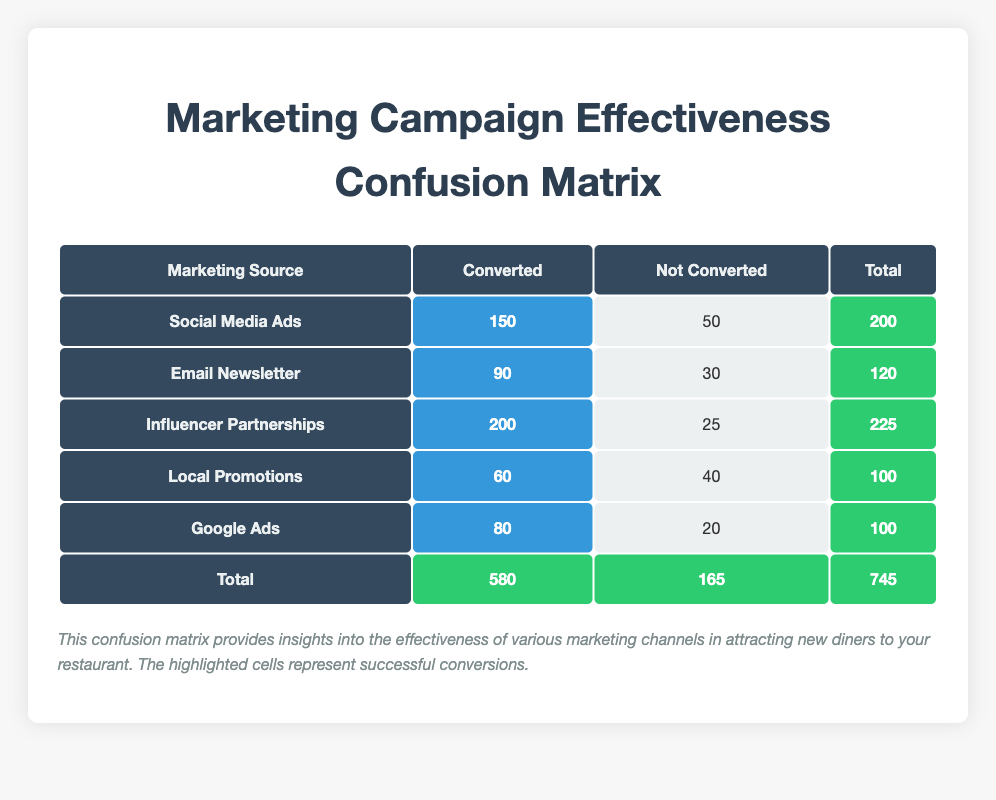What's the total number of conversions from Google Ads? In the table, the row corresponding to Google Ads shows that it converted 80 diners. This value is directly taken from the "Converted" column for Google Ads.
Answer: 80 Which marketing source had the highest number of conversions? By scanning the "Converted" column, Influencer Partnerships shows the highest count at 200. This is greater than the counts for the other marketing sources.
Answer: Influencer Partnerships What is the total number of diners reached through Social Media Ads? To find the total for Social Media Ads, we add the "Converted" (150) and "Not Converted" (50) counts together. Thus, 150 + 50 = 200.
Answer: 200 How many more diners were converted through Influencer Partnerships compared to Email Newsletter? For Influencer Partnerships, the conversions are 200 and for Email Newsletter, they are 90. The difference is calculated as 200 - 90 = 110.
Answer: 110 Is it true that Local Promotions converted more diners than Google Ads? The number of conversions for Local Promotions is 60 and for Google Ads, it is 80. Since 60 is less than 80, the statement is false.
Answer: No What percentage of diners using Email Newsletter did not convert? The total for Email Newsletter is 120 (90 converted + 30 not converted). The number who did not convert is 30. We calculate the percentage as (30 / 120) * 100 = 25%.
Answer: 25% How many total diners did not convert across all marketing sources? To find the total non-conversions, we sum up the "Not Converted" values: 50 (Social Media Ads) + 30 (Email Newsletter) + 25 (Influencer Partnerships) + 40 (Local Promotions) + 20 (Google Ads) = 165.
Answer: 165 What is the ratio of converted diners to non-converted diners for Local Promotions? Local Promotions converted 60 diners and did not convert 40. The ratio can be expressed as 60:40, which can also be simplified to 3:2.
Answer: 3:2 Which marketing source had the lowest number of total diners reached? Looking at the total counts in the last column, Local Promotions has the lowest total at 100, which is less than all other sources.
Answer: Local Promotions 